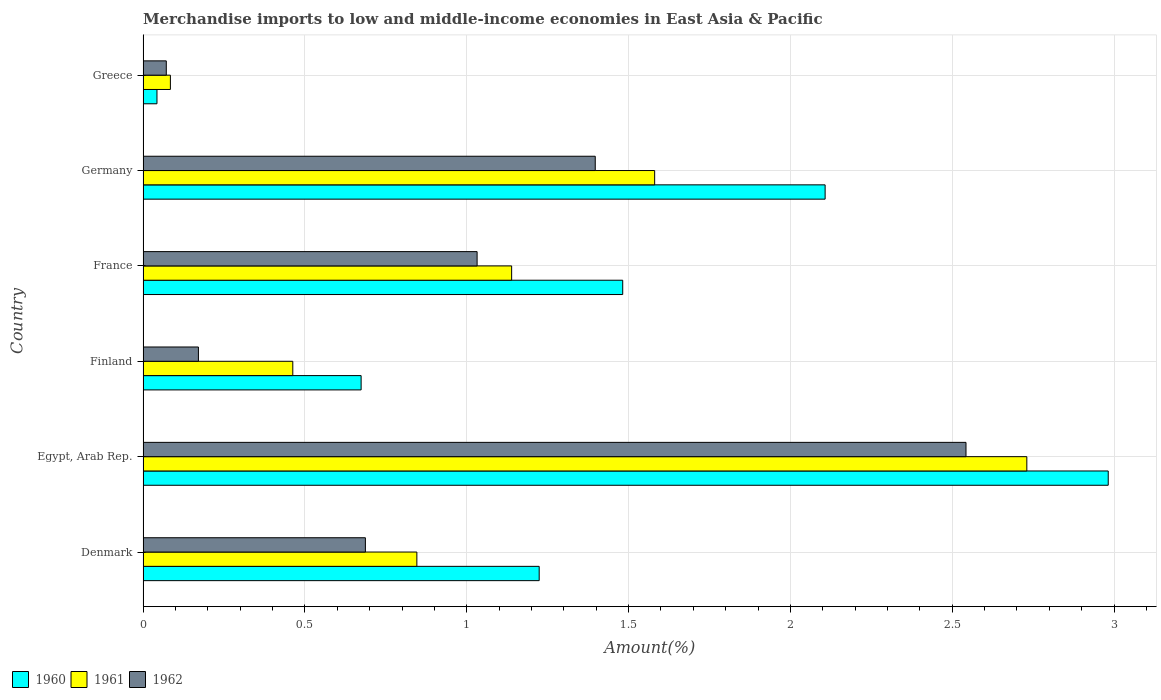How many different coloured bars are there?
Give a very brief answer. 3. How many groups of bars are there?
Provide a succinct answer. 6. Are the number of bars on each tick of the Y-axis equal?
Offer a very short reply. Yes. How many bars are there on the 6th tick from the top?
Make the answer very short. 3. How many bars are there on the 3rd tick from the bottom?
Give a very brief answer. 3. What is the percentage of amount earned from merchandise imports in 1962 in Denmark?
Give a very brief answer. 0.69. Across all countries, what is the maximum percentage of amount earned from merchandise imports in 1961?
Your answer should be very brief. 2.73. Across all countries, what is the minimum percentage of amount earned from merchandise imports in 1960?
Give a very brief answer. 0.04. In which country was the percentage of amount earned from merchandise imports in 1960 maximum?
Provide a succinct answer. Egypt, Arab Rep. What is the total percentage of amount earned from merchandise imports in 1961 in the graph?
Your answer should be very brief. 6.84. What is the difference between the percentage of amount earned from merchandise imports in 1962 in Denmark and that in Greece?
Keep it short and to the point. 0.62. What is the difference between the percentage of amount earned from merchandise imports in 1960 in Germany and the percentage of amount earned from merchandise imports in 1962 in France?
Offer a very short reply. 1.08. What is the average percentage of amount earned from merchandise imports in 1961 per country?
Keep it short and to the point. 1.14. What is the difference between the percentage of amount earned from merchandise imports in 1961 and percentage of amount earned from merchandise imports in 1960 in France?
Provide a succinct answer. -0.34. What is the ratio of the percentage of amount earned from merchandise imports in 1961 in Finland to that in France?
Provide a succinct answer. 0.41. Is the percentage of amount earned from merchandise imports in 1961 in Egypt, Arab Rep. less than that in France?
Your answer should be very brief. No. What is the difference between the highest and the second highest percentage of amount earned from merchandise imports in 1960?
Give a very brief answer. 0.87. What is the difference between the highest and the lowest percentage of amount earned from merchandise imports in 1962?
Ensure brevity in your answer.  2.47. Is the sum of the percentage of amount earned from merchandise imports in 1961 in Finland and Greece greater than the maximum percentage of amount earned from merchandise imports in 1960 across all countries?
Provide a short and direct response. No. What does the 3rd bar from the top in Egypt, Arab Rep. represents?
Offer a very short reply. 1960. Does the graph contain grids?
Offer a terse response. Yes. What is the title of the graph?
Give a very brief answer. Merchandise imports to low and middle-income economies in East Asia & Pacific. What is the label or title of the X-axis?
Offer a terse response. Amount(%). What is the label or title of the Y-axis?
Keep it short and to the point. Country. What is the Amount(%) of 1960 in Denmark?
Provide a succinct answer. 1.22. What is the Amount(%) in 1961 in Denmark?
Provide a short and direct response. 0.85. What is the Amount(%) of 1962 in Denmark?
Make the answer very short. 0.69. What is the Amount(%) in 1960 in Egypt, Arab Rep.?
Your answer should be very brief. 2.98. What is the Amount(%) in 1961 in Egypt, Arab Rep.?
Ensure brevity in your answer.  2.73. What is the Amount(%) of 1962 in Egypt, Arab Rep.?
Give a very brief answer. 2.54. What is the Amount(%) of 1960 in Finland?
Keep it short and to the point. 0.67. What is the Amount(%) in 1961 in Finland?
Your answer should be very brief. 0.46. What is the Amount(%) in 1962 in Finland?
Offer a terse response. 0.17. What is the Amount(%) of 1960 in France?
Your answer should be very brief. 1.48. What is the Amount(%) of 1961 in France?
Ensure brevity in your answer.  1.14. What is the Amount(%) of 1962 in France?
Provide a short and direct response. 1.03. What is the Amount(%) in 1960 in Germany?
Provide a short and direct response. 2.11. What is the Amount(%) of 1961 in Germany?
Make the answer very short. 1.58. What is the Amount(%) in 1962 in Germany?
Your response must be concise. 1.4. What is the Amount(%) in 1960 in Greece?
Offer a terse response. 0.04. What is the Amount(%) in 1961 in Greece?
Your answer should be very brief. 0.08. What is the Amount(%) of 1962 in Greece?
Your answer should be very brief. 0.07. Across all countries, what is the maximum Amount(%) of 1960?
Ensure brevity in your answer.  2.98. Across all countries, what is the maximum Amount(%) of 1961?
Give a very brief answer. 2.73. Across all countries, what is the maximum Amount(%) of 1962?
Your response must be concise. 2.54. Across all countries, what is the minimum Amount(%) in 1960?
Keep it short and to the point. 0.04. Across all countries, what is the minimum Amount(%) in 1961?
Your answer should be compact. 0.08. Across all countries, what is the minimum Amount(%) of 1962?
Make the answer very short. 0.07. What is the total Amount(%) of 1960 in the graph?
Your response must be concise. 8.51. What is the total Amount(%) of 1961 in the graph?
Give a very brief answer. 6.84. What is the total Amount(%) of 1962 in the graph?
Keep it short and to the point. 5.9. What is the difference between the Amount(%) of 1960 in Denmark and that in Egypt, Arab Rep.?
Your response must be concise. -1.76. What is the difference between the Amount(%) in 1961 in Denmark and that in Egypt, Arab Rep.?
Give a very brief answer. -1.88. What is the difference between the Amount(%) of 1962 in Denmark and that in Egypt, Arab Rep.?
Offer a terse response. -1.86. What is the difference between the Amount(%) of 1960 in Denmark and that in Finland?
Provide a short and direct response. 0.55. What is the difference between the Amount(%) in 1961 in Denmark and that in Finland?
Give a very brief answer. 0.38. What is the difference between the Amount(%) of 1962 in Denmark and that in Finland?
Offer a terse response. 0.52. What is the difference between the Amount(%) in 1960 in Denmark and that in France?
Give a very brief answer. -0.26. What is the difference between the Amount(%) of 1961 in Denmark and that in France?
Keep it short and to the point. -0.29. What is the difference between the Amount(%) of 1962 in Denmark and that in France?
Give a very brief answer. -0.35. What is the difference between the Amount(%) in 1960 in Denmark and that in Germany?
Offer a very short reply. -0.88. What is the difference between the Amount(%) in 1961 in Denmark and that in Germany?
Give a very brief answer. -0.73. What is the difference between the Amount(%) in 1962 in Denmark and that in Germany?
Offer a very short reply. -0.71. What is the difference between the Amount(%) in 1960 in Denmark and that in Greece?
Provide a succinct answer. 1.18. What is the difference between the Amount(%) of 1961 in Denmark and that in Greece?
Offer a very short reply. 0.76. What is the difference between the Amount(%) in 1962 in Denmark and that in Greece?
Offer a terse response. 0.62. What is the difference between the Amount(%) of 1960 in Egypt, Arab Rep. and that in Finland?
Give a very brief answer. 2.31. What is the difference between the Amount(%) of 1961 in Egypt, Arab Rep. and that in Finland?
Make the answer very short. 2.27. What is the difference between the Amount(%) of 1962 in Egypt, Arab Rep. and that in Finland?
Offer a very short reply. 2.37. What is the difference between the Amount(%) in 1960 in Egypt, Arab Rep. and that in France?
Make the answer very short. 1.5. What is the difference between the Amount(%) of 1961 in Egypt, Arab Rep. and that in France?
Your response must be concise. 1.59. What is the difference between the Amount(%) in 1962 in Egypt, Arab Rep. and that in France?
Offer a very short reply. 1.51. What is the difference between the Amount(%) of 1960 in Egypt, Arab Rep. and that in Germany?
Ensure brevity in your answer.  0.87. What is the difference between the Amount(%) in 1961 in Egypt, Arab Rep. and that in Germany?
Your answer should be compact. 1.15. What is the difference between the Amount(%) of 1962 in Egypt, Arab Rep. and that in Germany?
Offer a very short reply. 1.15. What is the difference between the Amount(%) in 1960 in Egypt, Arab Rep. and that in Greece?
Your answer should be very brief. 2.94. What is the difference between the Amount(%) of 1961 in Egypt, Arab Rep. and that in Greece?
Keep it short and to the point. 2.65. What is the difference between the Amount(%) of 1962 in Egypt, Arab Rep. and that in Greece?
Your response must be concise. 2.47. What is the difference between the Amount(%) in 1960 in Finland and that in France?
Offer a very short reply. -0.81. What is the difference between the Amount(%) of 1961 in Finland and that in France?
Offer a very short reply. -0.68. What is the difference between the Amount(%) in 1962 in Finland and that in France?
Offer a terse response. -0.86. What is the difference between the Amount(%) of 1960 in Finland and that in Germany?
Provide a short and direct response. -1.43. What is the difference between the Amount(%) in 1961 in Finland and that in Germany?
Provide a short and direct response. -1.12. What is the difference between the Amount(%) in 1962 in Finland and that in Germany?
Your answer should be very brief. -1.23. What is the difference between the Amount(%) in 1960 in Finland and that in Greece?
Offer a very short reply. 0.63. What is the difference between the Amount(%) in 1961 in Finland and that in Greece?
Make the answer very short. 0.38. What is the difference between the Amount(%) in 1962 in Finland and that in Greece?
Your answer should be very brief. 0.1. What is the difference between the Amount(%) in 1960 in France and that in Germany?
Provide a short and direct response. -0.63. What is the difference between the Amount(%) in 1961 in France and that in Germany?
Provide a succinct answer. -0.44. What is the difference between the Amount(%) in 1962 in France and that in Germany?
Give a very brief answer. -0.36. What is the difference between the Amount(%) in 1960 in France and that in Greece?
Give a very brief answer. 1.44. What is the difference between the Amount(%) of 1961 in France and that in Greece?
Offer a terse response. 1.05. What is the difference between the Amount(%) in 1962 in France and that in Greece?
Offer a very short reply. 0.96. What is the difference between the Amount(%) of 1960 in Germany and that in Greece?
Your answer should be compact. 2.06. What is the difference between the Amount(%) of 1961 in Germany and that in Greece?
Offer a very short reply. 1.5. What is the difference between the Amount(%) in 1962 in Germany and that in Greece?
Your answer should be compact. 1.33. What is the difference between the Amount(%) of 1960 in Denmark and the Amount(%) of 1961 in Egypt, Arab Rep.?
Provide a short and direct response. -1.51. What is the difference between the Amount(%) in 1960 in Denmark and the Amount(%) in 1962 in Egypt, Arab Rep.?
Your response must be concise. -1.32. What is the difference between the Amount(%) of 1961 in Denmark and the Amount(%) of 1962 in Egypt, Arab Rep.?
Offer a terse response. -1.7. What is the difference between the Amount(%) in 1960 in Denmark and the Amount(%) in 1961 in Finland?
Provide a succinct answer. 0.76. What is the difference between the Amount(%) in 1960 in Denmark and the Amount(%) in 1962 in Finland?
Give a very brief answer. 1.05. What is the difference between the Amount(%) of 1961 in Denmark and the Amount(%) of 1962 in Finland?
Ensure brevity in your answer.  0.67. What is the difference between the Amount(%) of 1960 in Denmark and the Amount(%) of 1961 in France?
Give a very brief answer. 0.09. What is the difference between the Amount(%) in 1960 in Denmark and the Amount(%) in 1962 in France?
Give a very brief answer. 0.19. What is the difference between the Amount(%) of 1961 in Denmark and the Amount(%) of 1962 in France?
Make the answer very short. -0.19. What is the difference between the Amount(%) in 1960 in Denmark and the Amount(%) in 1961 in Germany?
Offer a terse response. -0.36. What is the difference between the Amount(%) of 1960 in Denmark and the Amount(%) of 1962 in Germany?
Offer a very short reply. -0.17. What is the difference between the Amount(%) in 1961 in Denmark and the Amount(%) in 1962 in Germany?
Provide a short and direct response. -0.55. What is the difference between the Amount(%) of 1960 in Denmark and the Amount(%) of 1961 in Greece?
Offer a terse response. 1.14. What is the difference between the Amount(%) in 1960 in Denmark and the Amount(%) in 1962 in Greece?
Your answer should be very brief. 1.15. What is the difference between the Amount(%) of 1961 in Denmark and the Amount(%) of 1962 in Greece?
Offer a terse response. 0.77. What is the difference between the Amount(%) of 1960 in Egypt, Arab Rep. and the Amount(%) of 1961 in Finland?
Your answer should be very brief. 2.52. What is the difference between the Amount(%) of 1960 in Egypt, Arab Rep. and the Amount(%) of 1962 in Finland?
Make the answer very short. 2.81. What is the difference between the Amount(%) of 1961 in Egypt, Arab Rep. and the Amount(%) of 1962 in Finland?
Offer a very short reply. 2.56. What is the difference between the Amount(%) in 1960 in Egypt, Arab Rep. and the Amount(%) in 1961 in France?
Give a very brief answer. 1.84. What is the difference between the Amount(%) of 1960 in Egypt, Arab Rep. and the Amount(%) of 1962 in France?
Your response must be concise. 1.95. What is the difference between the Amount(%) of 1961 in Egypt, Arab Rep. and the Amount(%) of 1962 in France?
Offer a very short reply. 1.7. What is the difference between the Amount(%) in 1960 in Egypt, Arab Rep. and the Amount(%) in 1961 in Germany?
Your answer should be very brief. 1.4. What is the difference between the Amount(%) in 1960 in Egypt, Arab Rep. and the Amount(%) in 1962 in Germany?
Provide a short and direct response. 1.58. What is the difference between the Amount(%) of 1961 in Egypt, Arab Rep. and the Amount(%) of 1962 in Germany?
Keep it short and to the point. 1.33. What is the difference between the Amount(%) in 1960 in Egypt, Arab Rep. and the Amount(%) in 1961 in Greece?
Provide a succinct answer. 2.9. What is the difference between the Amount(%) in 1960 in Egypt, Arab Rep. and the Amount(%) in 1962 in Greece?
Your answer should be compact. 2.91. What is the difference between the Amount(%) of 1961 in Egypt, Arab Rep. and the Amount(%) of 1962 in Greece?
Ensure brevity in your answer.  2.66. What is the difference between the Amount(%) in 1960 in Finland and the Amount(%) in 1961 in France?
Keep it short and to the point. -0.47. What is the difference between the Amount(%) in 1960 in Finland and the Amount(%) in 1962 in France?
Give a very brief answer. -0.36. What is the difference between the Amount(%) in 1961 in Finland and the Amount(%) in 1962 in France?
Your answer should be compact. -0.57. What is the difference between the Amount(%) in 1960 in Finland and the Amount(%) in 1961 in Germany?
Your answer should be compact. -0.91. What is the difference between the Amount(%) of 1960 in Finland and the Amount(%) of 1962 in Germany?
Keep it short and to the point. -0.72. What is the difference between the Amount(%) of 1961 in Finland and the Amount(%) of 1962 in Germany?
Ensure brevity in your answer.  -0.93. What is the difference between the Amount(%) in 1960 in Finland and the Amount(%) in 1961 in Greece?
Provide a short and direct response. 0.59. What is the difference between the Amount(%) of 1960 in Finland and the Amount(%) of 1962 in Greece?
Offer a terse response. 0.6. What is the difference between the Amount(%) in 1961 in Finland and the Amount(%) in 1962 in Greece?
Your answer should be compact. 0.39. What is the difference between the Amount(%) in 1960 in France and the Amount(%) in 1961 in Germany?
Your response must be concise. -0.1. What is the difference between the Amount(%) of 1960 in France and the Amount(%) of 1962 in Germany?
Keep it short and to the point. 0.08. What is the difference between the Amount(%) in 1961 in France and the Amount(%) in 1962 in Germany?
Your answer should be very brief. -0.26. What is the difference between the Amount(%) of 1960 in France and the Amount(%) of 1961 in Greece?
Provide a succinct answer. 1.4. What is the difference between the Amount(%) in 1960 in France and the Amount(%) in 1962 in Greece?
Provide a short and direct response. 1.41. What is the difference between the Amount(%) in 1961 in France and the Amount(%) in 1962 in Greece?
Provide a succinct answer. 1.07. What is the difference between the Amount(%) in 1960 in Germany and the Amount(%) in 1961 in Greece?
Provide a succinct answer. 2.02. What is the difference between the Amount(%) in 1960 in Germany and the Amount(%) in 1962 in Greece?
Ensure brevity in your answer.  2.04. What is the difference between the Amount(%) of 1961 in Germany and the Amount(%) of 1962 in Greece?
Provide a succinct answer. 1.51. What is the average Amount(%) of 1960 per country?
Your answer should be compact. 1.42. What is the average Amount(%) of 1961 per country?
Your answer should be very brief. 1.14. What is the average Amount(%) of 1962 per country?
Provide a short and direct response. 0.98. What is the difference between the Amount(%) of 1960 and Amount(%) of 1961 in Denmark?
Keep it short and to the point. 0.38. What is the difference between the Amount(%) in 1960 and Amount(%) in 1962 in Denmark?
Give a very brief answer. 0.54. What is the difference between the Amount(%) in 1961 and Amount(%) in 1962 in Denmark?
Your answer should be very brief. 0.16. What is the difference between the Amount(%) in 1960 and Amount(%) in 1961 in Egypt, Arab Rep.?
Your response must be concise. 0.25. What is the difference between the Amount(%) of 1960 and Amount(%) of 1962 in Egypt, Arab Rep.?
Your answer should be compact. 0.44. What is the difference between the Amount(%) of 1961 and Amount(%) of 1962 in Egypt, Arab Rep.?
Provide a succinct answer. 0.19. What is the difference between the Amount(%) in 1960 and Amount(%) in 1961 in Finland?
Offer a terse response. 0.21. What is the difference between the Amount(%) in 1960 and Amount(%) in 1962 in Finland?
Offer a very short reply. 0.5. What is the difference between the Amount(%) in 1961 and Amount(%) in 1962 in Finland?
Provide a short and direct response. 0.29. What is the difference between the Amount(%) in 1960 and Amount(%) in 1961 in France?
Offer a very short reply. 0.34. What is the difference between the Amount(%) of 1960 and Amount(%) of 1962 in France?
Offer a terse response. 0.45. What is the difference between the Amount(%) in 1961 and Amount(%) in 1962 in France?
Your answer should be compact. 0.11. What is the difference between the Amount(%) of 1960 and Amount(%) of 1961 in Germany?
Your answer should be compact. 0.53. What is the difference between the Amount(%) in 1960 and Amount(%) in 1962 in Germany?
Keep it short and to the point. 0.71. What is the difference between the Amount(%) in 1961 and Amount(%) in 1962 in Germany?
Make the answer very short. 0.18. What is the difference between the Amount(%) of 1960 and Amount(%) of 1961 in Greece?
Offer a terse response. -0.04. What is the difference between the Amount(%) of 1960 and Amount(%) of 1962 in Greece?
Ensure brevity in your answer.  -0.03. What is the difference between the Amount(%) of 1961 and Amount(%) of 1962 in Greece?
Your answer should be very brief. 0.01. What is the ratio of the Amount(%) in 1960 in Denmark to that in Egypt, Arab Rep.?
Give a very brief answer. 0.41. What is the ratio of the Amount(%) of 1961 in Denmark to that in Egypt, Arab Rep.?
Give a very brief answer. 0.31. What is the ratio of the Amount(%) in 1962 in Denmark to that in Egypt, Arab Rep.?
Make the answer very short. 0.27. What is the ratio of the Amount(%) in 1960 in Denmark to that in Finland?
Offer a terse response. 1.82. What is the ratio of the Amount(%) in 1961 in Denmark to that in Finland?
Your answer should be very brief. 1.83. What is the ratio of the Amount(%) of 1962 in Denmark to that in Finland?
Offer a terse response. 4.02. What is the ratio of the Amount(%) of 1960 in Denmark to that in France?
Give a very brief answer. 0.83. What is the ratio of the Amount(%) of 1961 in Denmark to that in France?
Offer a very short reply. 0.74. What is the ratio of the Amount(%) in 1962 in Denmark to that in France?
Give a very brief answer. 0.67. What is the ratio of the Amount(%) of 1960 in Denmark to that in Germany?
Offer a terse response. 0.58. What is the ratio of the Amount(%) in 1961 in Denmark to that in Germany?
Give a very brief answer. 0.54. What is the ratio of the Amount(%) of 1962 in Denmark to that in Germany?
Offer a terse response. 0.49. What is the ratio of the Amount(%) of 1960 in Denmark to that in Greece?
Your answer should be very brief. 28.49. What is the ratio of the Amount(%) of 1961 in Denmark to that in Greece?
Keep it short and to the point. 10.02. What is the ratio of the Amount(%) in 1962 in Denmark to that in Greece?
Give a very brief answer. 9.57. What is the ratio of the Amount(%) in 1960 in Egypt, Arab Rep. to that in Finland?
Provide a short and direct response. 4.43. What is the ratio of the Amount(%) of 1961 in Egypt, Arab Rep. to that in Finland?
Provide a short and direct response. 5.9. What is the ratio of the Amount(%) of 1962 in Egypt, Arab Rep. to that in Finland?
Your answer should be very brief. 14.87. What is the ratio of the Amount(%) in 1960 in Egypt, Arab Rep. to that in France?
Provide a succinct answer. 2.01. What is the ratio of the Amount(%) in 1961 in Egypt, Arab Rep. to that in France?
Provide a succinct answer. 2.4. What is the ratio of the Amount(%) of 1962 in Egypt, Arab Rep. to that in France?
Offer a terse response. 2.46. What is the ratio of the Amount(%) of 1960 in Egypt, Arab Rep. to that in Germany?
Ensure brevity in your answer.  1.42. What is the ratio of the Amount(%) of 1961 in Egypt, Arab Rep. to that in Germany?
Ensure brevity in your answer.  1.73. What is the ratio of the Amount(%) in 1962 in Egypt, Arab Rep. to that in Germany?
Offer a very short reply. 1.82. What is the ratio of the Amount(%) of 1960 in Egypt, Arab Rep. to that in Greece?
Make the answer very short. 69.41. What is the ratio of the Amount(%) of 1961 in Egypt, Arab Rep. to that in Greece?
Your response must be concise. 32.33. What is the ratio of the Amount(%) in 1962 in Egypt, Arab Rep. to that in Greece?
Give a very brief answer. 35.41. What is the ratio of the Amount(%) in 1960 in Finland to that in France?
Provide a short and direct response. 0.45. What is the ratio of the Amount(%) in 1961 in Finland to that in France?
Ensure brevity in your answer.  0.41. What is the ratio of the Amount(%) of 1962 in Finland to that in France?
Provide a short and direct response. 0.17. What is the ratio of the Amount(%) in 1960 in Finland to that in Germany?
Your answer should be very brief. 0.32. What is the ratio of the Amount(%) in 1961 in Finland to that in Germany?
Provide a short and direct response. 0.29. What is the ratio of the Amount(%) in 1962 in Finland to that in Germany?
Give a very brief answer. 0.12. What is the ratio of the Amount(%) in 1960 in Finland to that in Greece?
Your response must be concise. 15.68. What is the ratio of the Amount(%) of 1961 in Finland to that in Greece?
Give a very brief answer. 5.48. What is the ratio of the Amount(%) in 1962 in Finland to that in Greece?
Ensure brevity in your answer.  2.38. What is the ratio of the Amount(%) of 1960 in France to that in Germany?
Ensure brevity in your answer.  0.7. What is the ratio of the Amount(%) in 1961 in France to that in Germany?
Your response must be concise. 0.72. What is the ratio of the Amount(%) of 1962 in France to that in Germany?
Make the answer very short. 0.74. What is the ratio of the Amount(%) in 1960 in France to that in Greece?
Give a very brief answer. 34.49. What is the ratio of the Amount(%) in 1961 in France to that in Greece?
Ensure brevity in your answer.  13.48. What is the ratio of the Amount(%) of 1962 in France to that in Greece?
Provide a short and direct response. 14.37. What is the ratio of the Amount(%) in 1960 in Germany to that in Greece?
Your answer should be compact. 49.05. What is the ratio of the Amount(%) of 1961 in Germany to that in Greece?
Offer a terse response. 18.72. What is the ratio of the Amount(%) of 1962 in Germany to that in Greece?
Your answer should be very brief. 19.46. What is the difference between the highest and the second highest Amount(%) in 1960?
Your answer should be very brief. 0.87. What is the difference between the highest and the second highest Amount(%) in 1961?
Offer a terse response. 1.15. What is the difference between the highest and the second highest Amount(%) of 1962?
Provide a succinct answer. 1.15. What is the difference between the highest and the lowest Amount(%) in 1960?
Offer a very short reply. 2.94. What is the difference between the highest and the lowest Amount(%) in 1961?
Keep it short and to the point. 2.65. What is the difference between the highest and the lowest Amount(%) in 1962?
Provide a succinct answer. 2.47. 